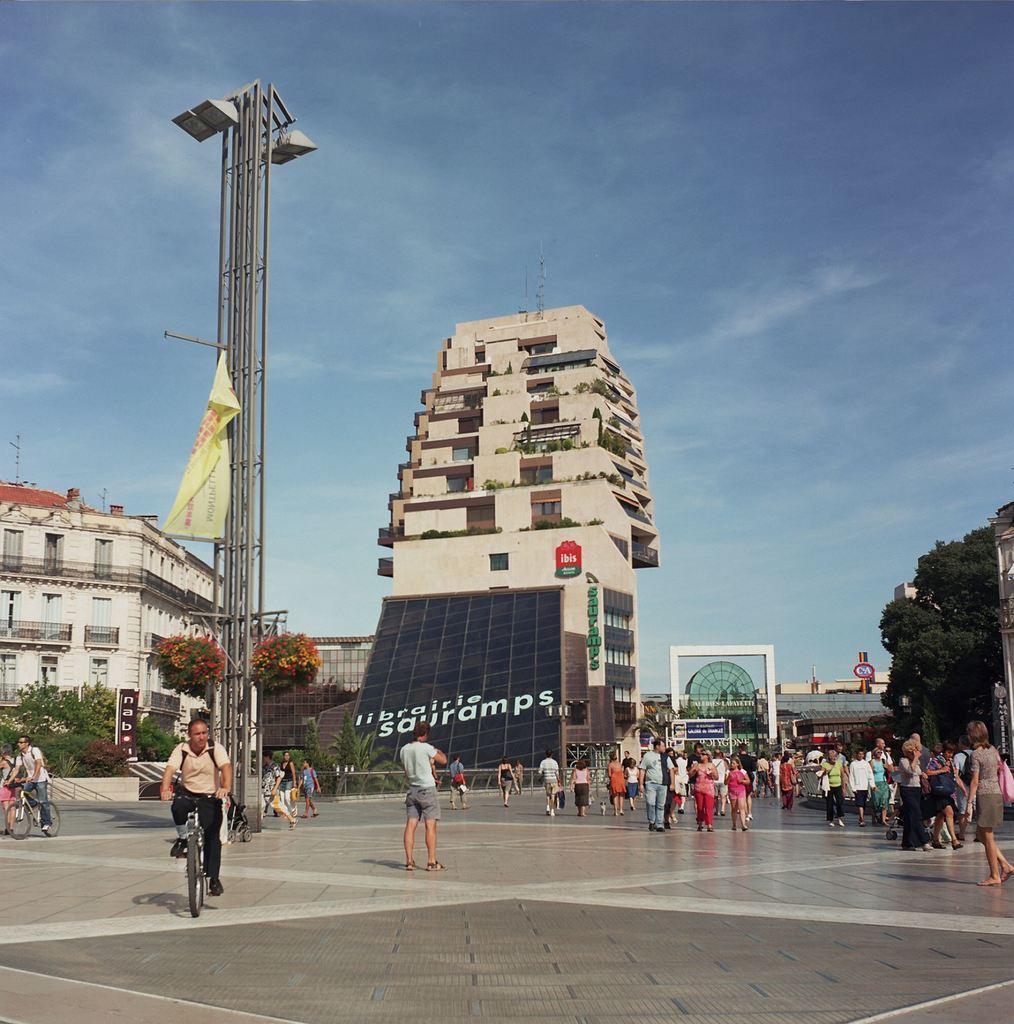Could you give a brief overview of what you see in this image? In this image we can see a few people, two of them are riding on bicycles, there are buildings, poles, lights, boards with text on them, there are plants, trees, also we can see the sky. 